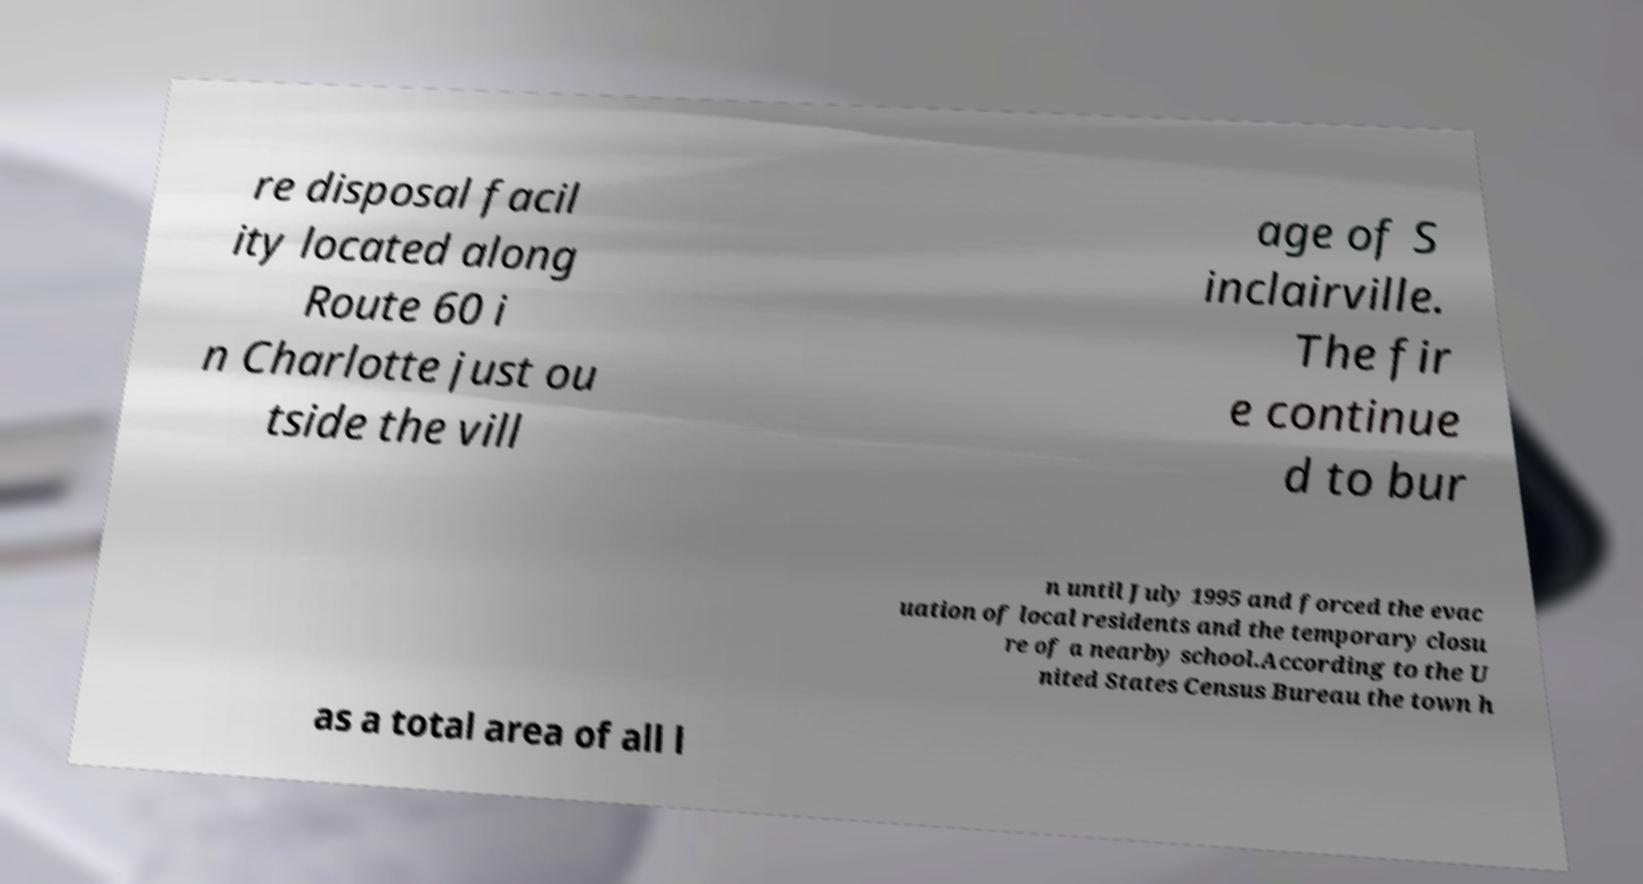Could you assist in decoding the text presented in this image and type it out clearly? re disposal facil ity located along Route 60 i n Charlotte just ou tside the vill age of S inclairville. The fir e continue d to bur n until July 1995 and forced the evac uation of local residents and the temporary closu re of a nearby school.According to the U nited States Census Bureau the town h as a total area of all l 